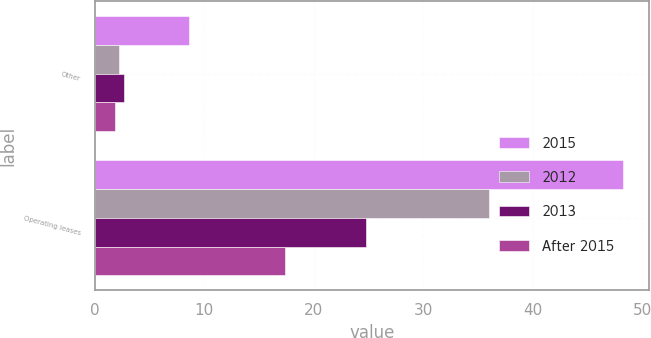<chart> <loc_0><loc_0><loc_500><loc_500><stacked_bar_chart><ecel><fcel>Other<fcel>Operating leases<nl><fcel>2015<fcel>8.6<fcel>48.2<nl><fcel>2012<fcel>2.2<fcel>36<nl><fcel>2013<fcel>2.7<fcel>24.8<nl><fcel>After 2015<fcel>1.9<fcel>17.4<nl></chart> 